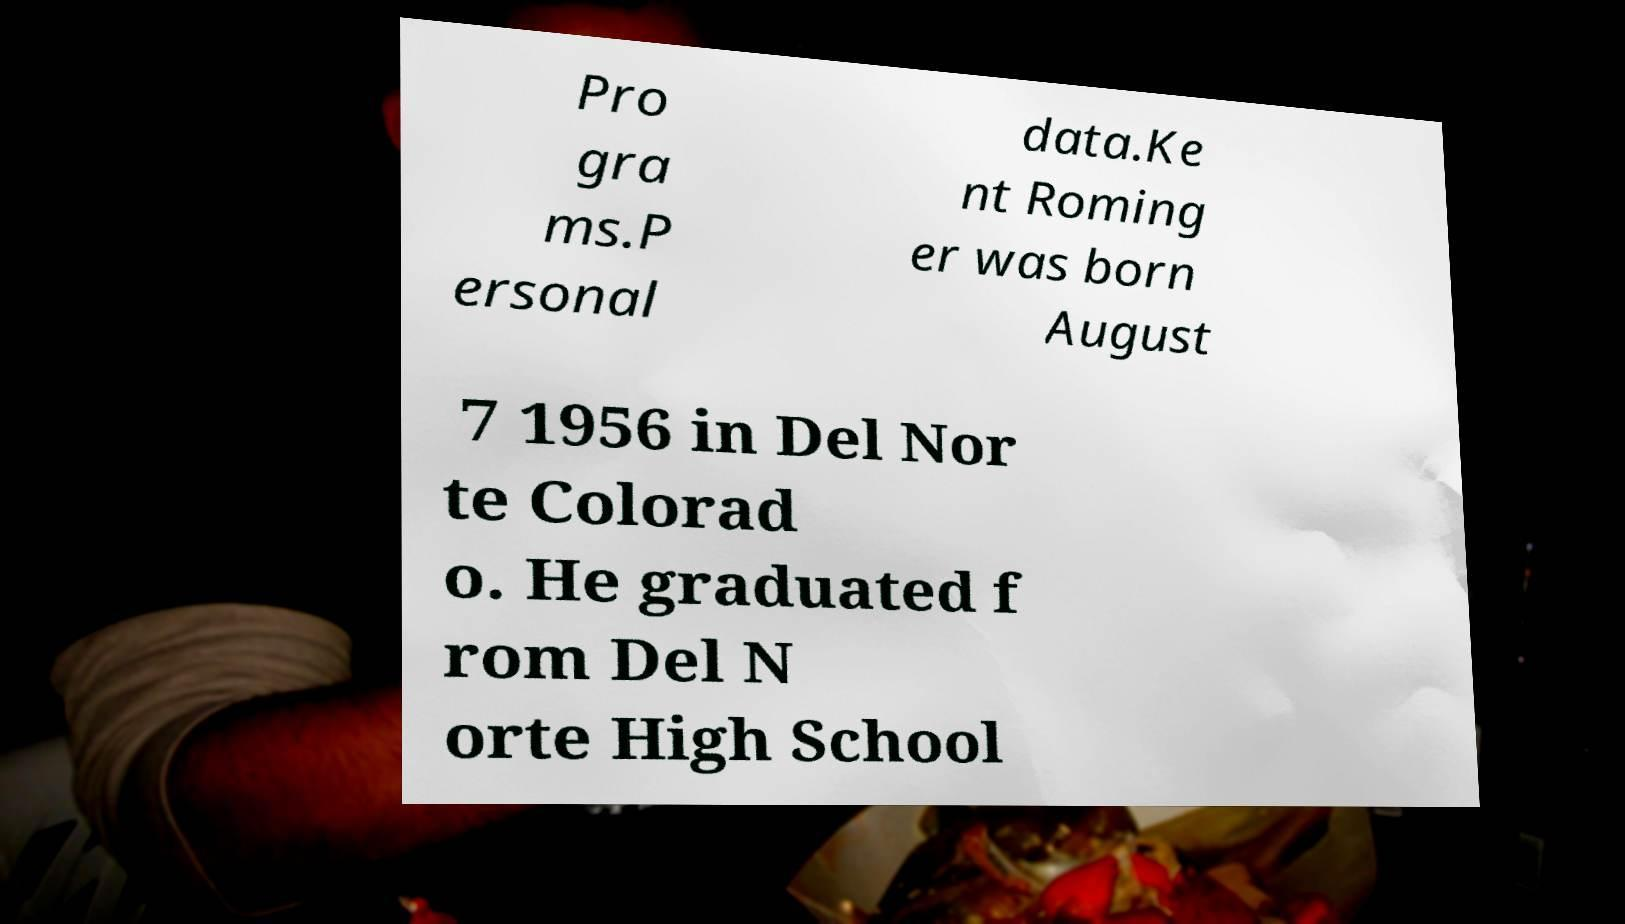Can you read and provide the text displayed in the image?This photo seems to have some interesting text. Can you extract and type it out for me? Pro gra ms.P ersonal data.Ke nt Roming er was born August 7 1956 in Del Nor te Colorad o. He graduated f rom Del N orte High School 